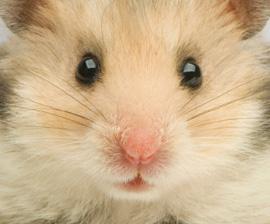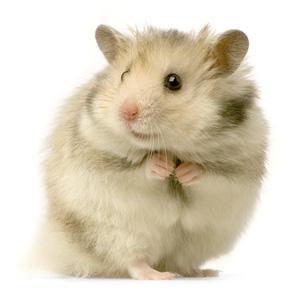The first image is the image on the left, the second image is the image on the right. Given the left and right images, does the statement "The rodent-type pet in the right image is on a green backdrop." hold true? Answer yes or no. No. 